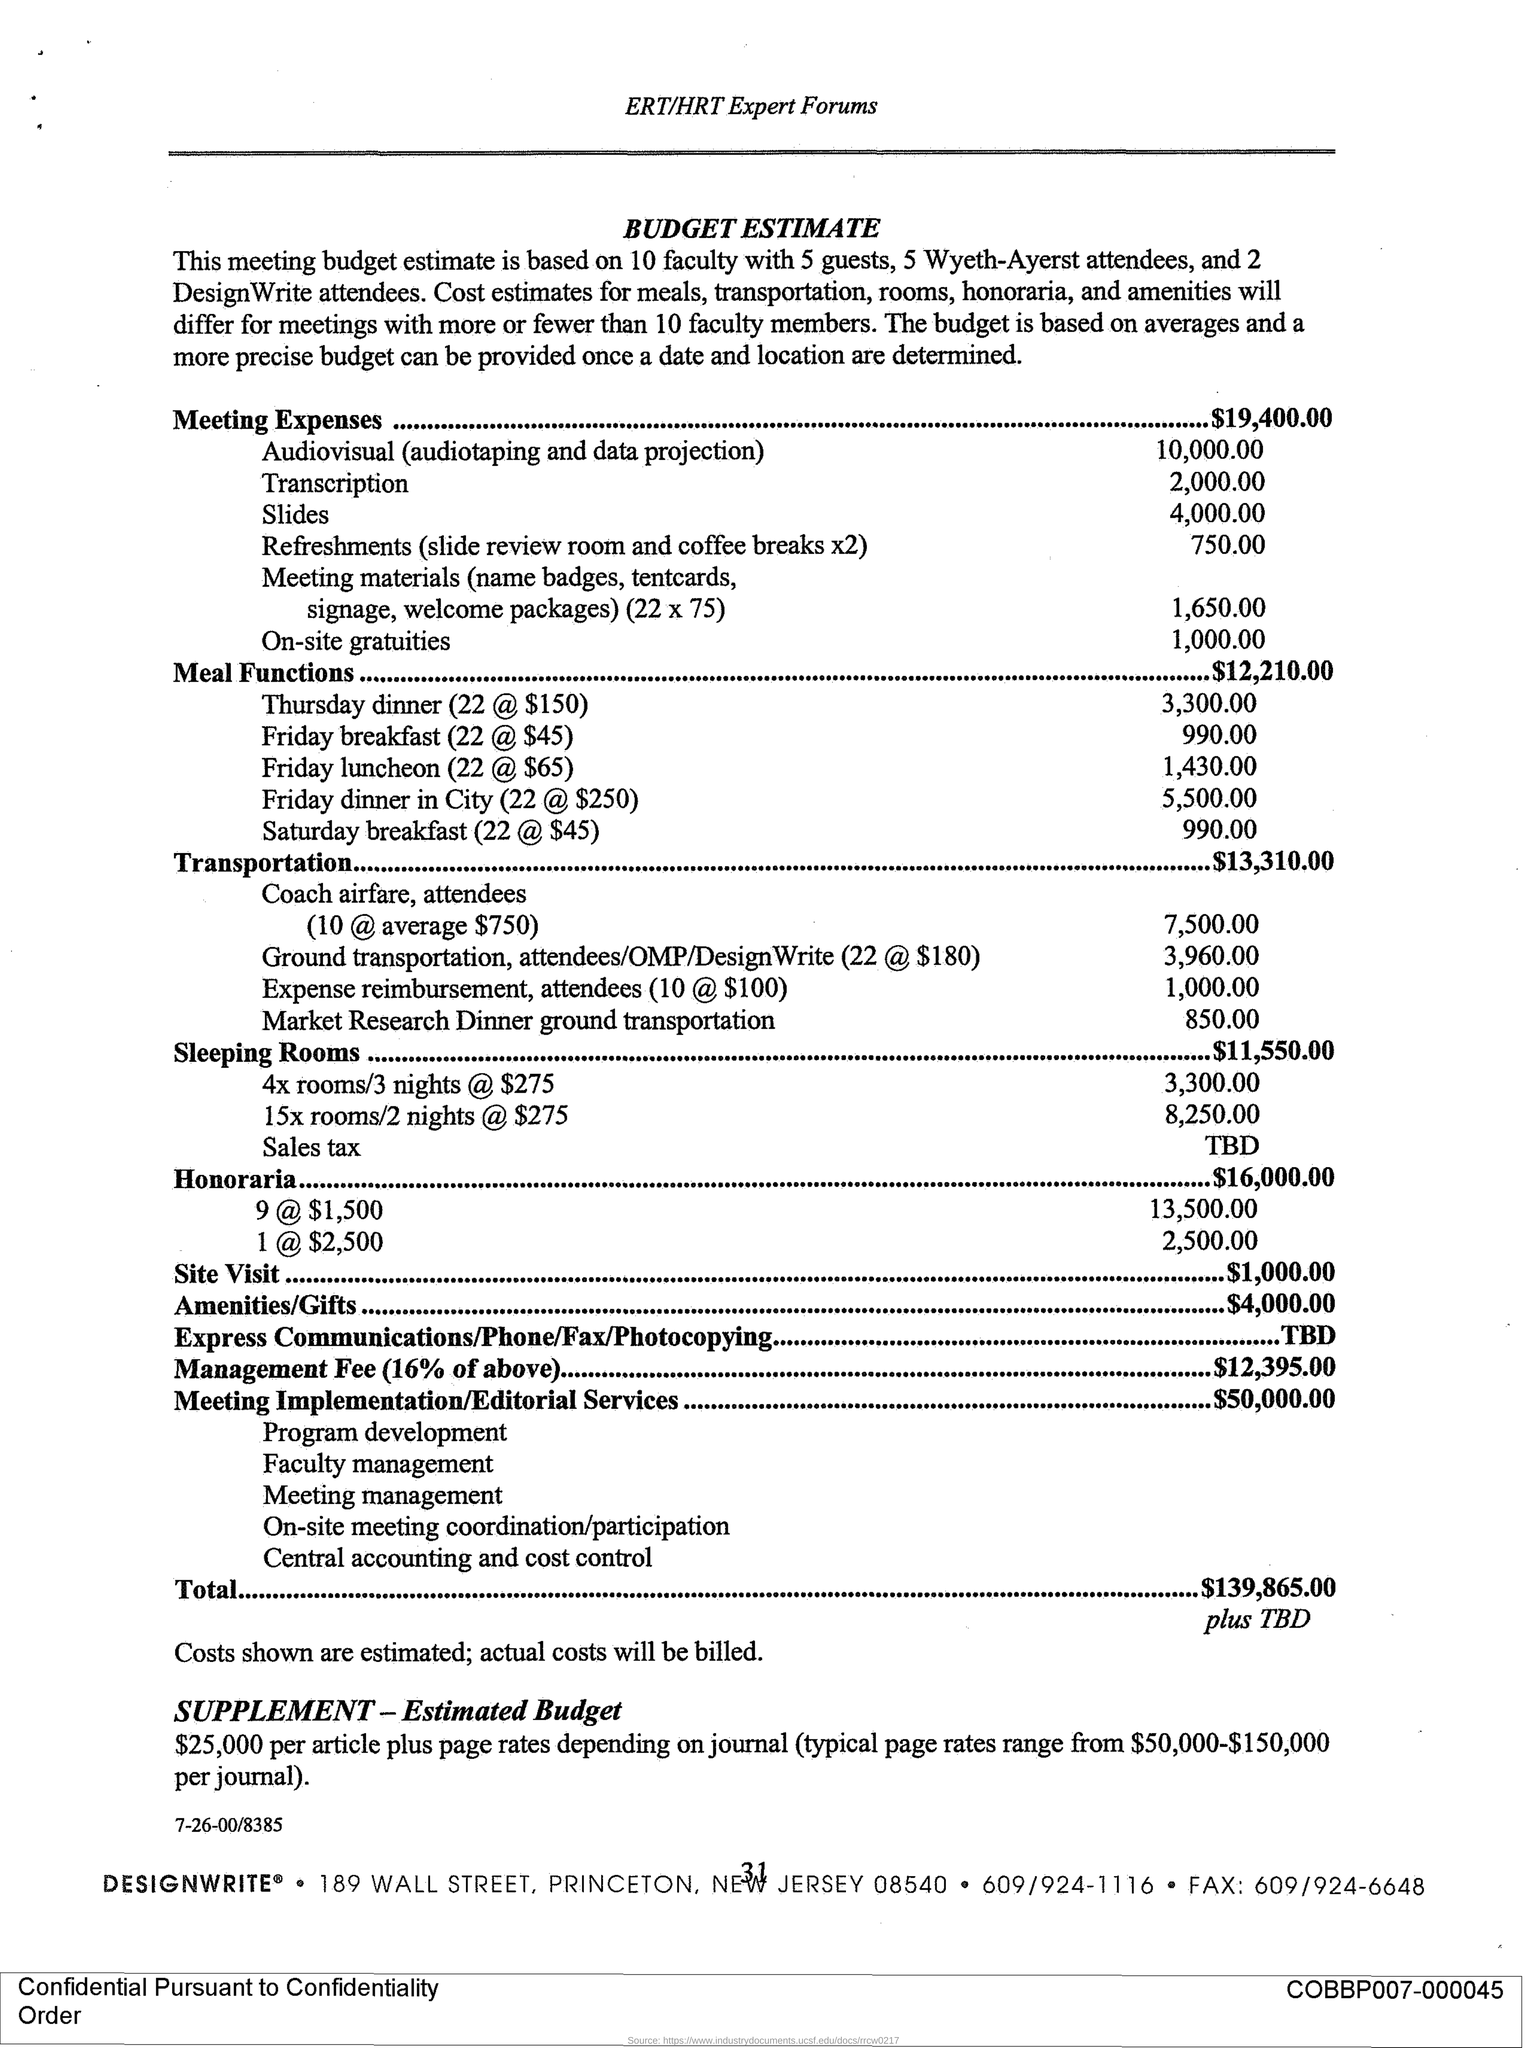How much are the meeting expenses?
Your answer should be compact. $19,400.00. How much is the typical page rates as given in "Supplement estimated budget"?
Ensure brevity in your answer.  Page rates range from $50,000-$150,000 per journal. 